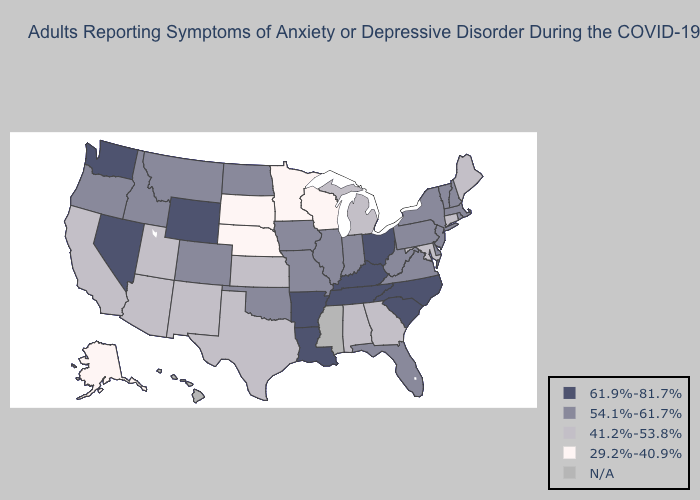What is the lowest value in the Northeast?
Quick response, please. 41.2%-53.8%. Which states have the lowest value in the USA?
Concise answer only. Alaska, Minnesota, Nebraska, South Dakota, Wisconsin. Which states have the lowest value in the USA?
Short answer required. Alaska, Minnesota, Nebraska, South Dakota, Wisconsin. Name the states that have a value in the range 54.1%-61.7%?
Quick response, please. Colorado, Delaware, Florida, Idaho, Illinois, Indiana, Iowa, Massachusetts, Missouri, Montana, New Hampshire, New Jersey, New York, North Dakota, Oklahoma, Oregon, Pennsylvania, Rhode Island, Vermont, Virginia, West Virginia. What is the highest value in the Northeast ?
Answer briefly. 54.1%-61.7%. What is the value of Hawaii?
Answer briefly. N/A. Among the states that border Arizona , does Colorado have the lowest value?
Give a very brief answer. No. Among the states that border Indiana , which have the lowest value?
Keep it brief. Michigan. Is the legend a continuous bar?
Short answer required. No. Among the states that border Rhode Island , which have the lowest value?
Quick response, please. Connecticut. Name the states that have a value in the range 54.1%-61.7%?
Write a very short answer. Colorado, Delaware, Florida, Idaho, Illinois, Indiana, Iowa, Massachusetts, Missouri, Montana, New Hampshire, New Jersey, New York, North Dakota, Oklahoma, Oregon, Pennsylvania, Rhode Island, Vermont, Virginia, West Virginia. What is the value of North Dakota?
Give a very brief answer. 54.1%-61.7%. What is the highest value in the USA?
Write a very short answer. 61.9%-81.7%. How many symbols are there in the legend?
Keep it brief. 5. 